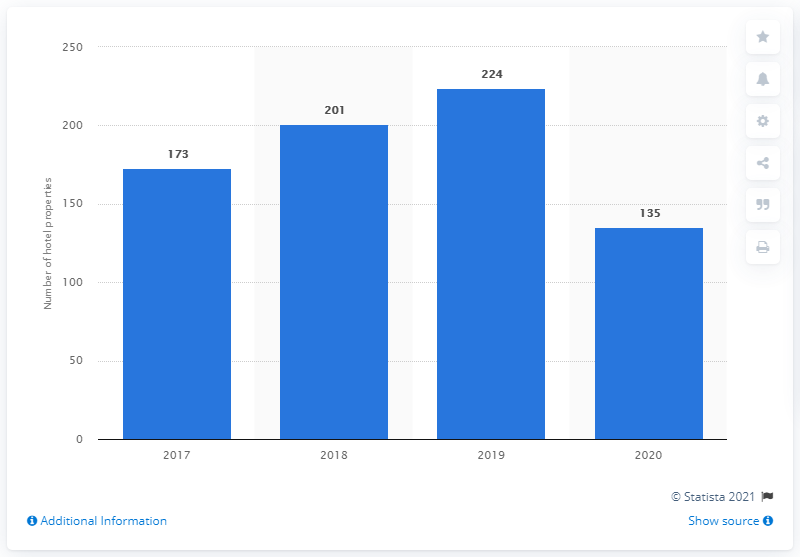List a handful of essential elements in this visual. In 2020, there were 135 hotels in India that signed with the brand. 